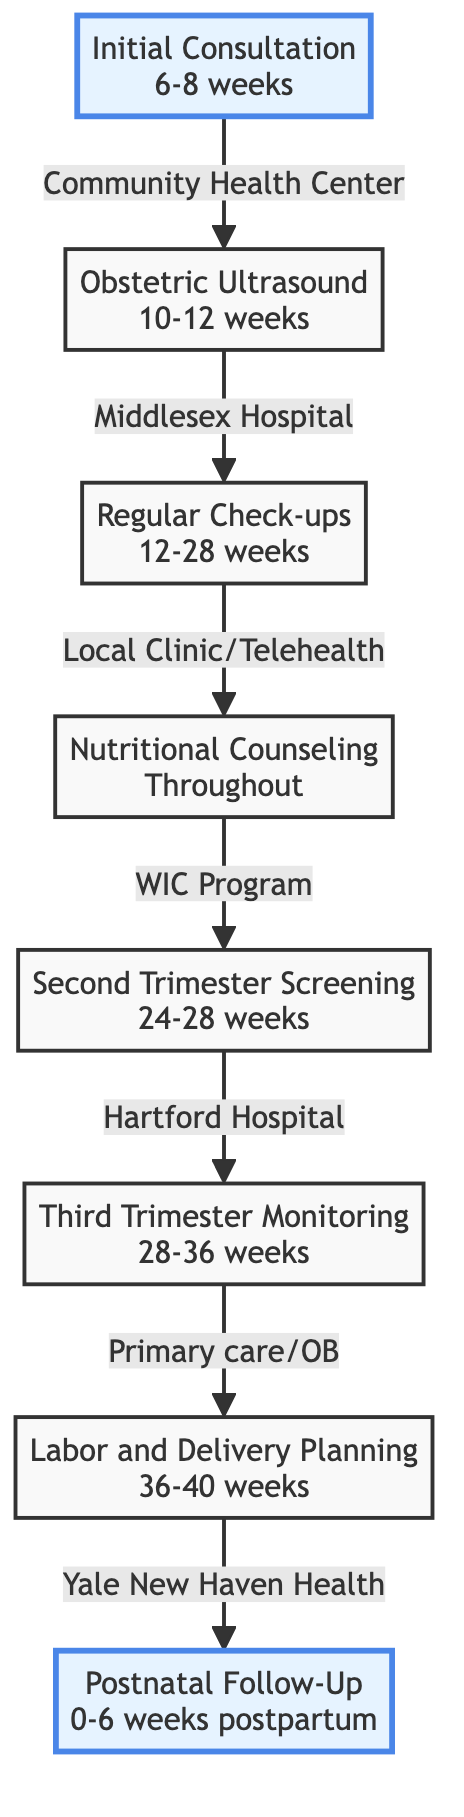What is the first step in the Prenatal Care Pathway? The diagram shows that the first step is labeled "Initial Consultation," which occurs at 6-8 weeks of pregnancy.
Answer: Initial Consultation What location is specified for the Obstetric Ultrasound? According to the diagram, the Obstetric Ultrasound is performed at Middlesex Hospital Radiology Dept.
Answer: Middlesex Hospital Radiology Dept How many total steps are in the Prenatal Care Pathway? By counting the steps numbered 1 through 8 in the diagram, we determine there are a total of 8 steps.
Answer: 8 What is the timeline for Regular Check-ups? The diagram indicates that Regular Check-ups take place from 12-28 weeks of pregnancy.
Answer: 12-28 weeks Which step involves nutritional counseling? The diagram identifies "Nutritional Counseling" as the fourth step in the Prenatal Care Pathway.
Answer: Nutritional Counseling What type of monitoring occurs during the Third Trimester? The diagram specifies "Bi-weekly visits for fetal monitoring" as part of the Third Trimester Monitoring step.
Answer: Bi-weekly visits for fetal monitoring At which medical facility do discussions about Labor and Delivery Planning occur? According to the diagram, Labor and Delivery Planning discussions are held at Yale New Haven Health System.
Answer: Yale New Haven Health System When should the Postnatal Follow-Up occur after delivery? The diagram states that Postnatal Follow-Up should be scheduled within 6 weeks after delivery.
Answer: 6 weeks 